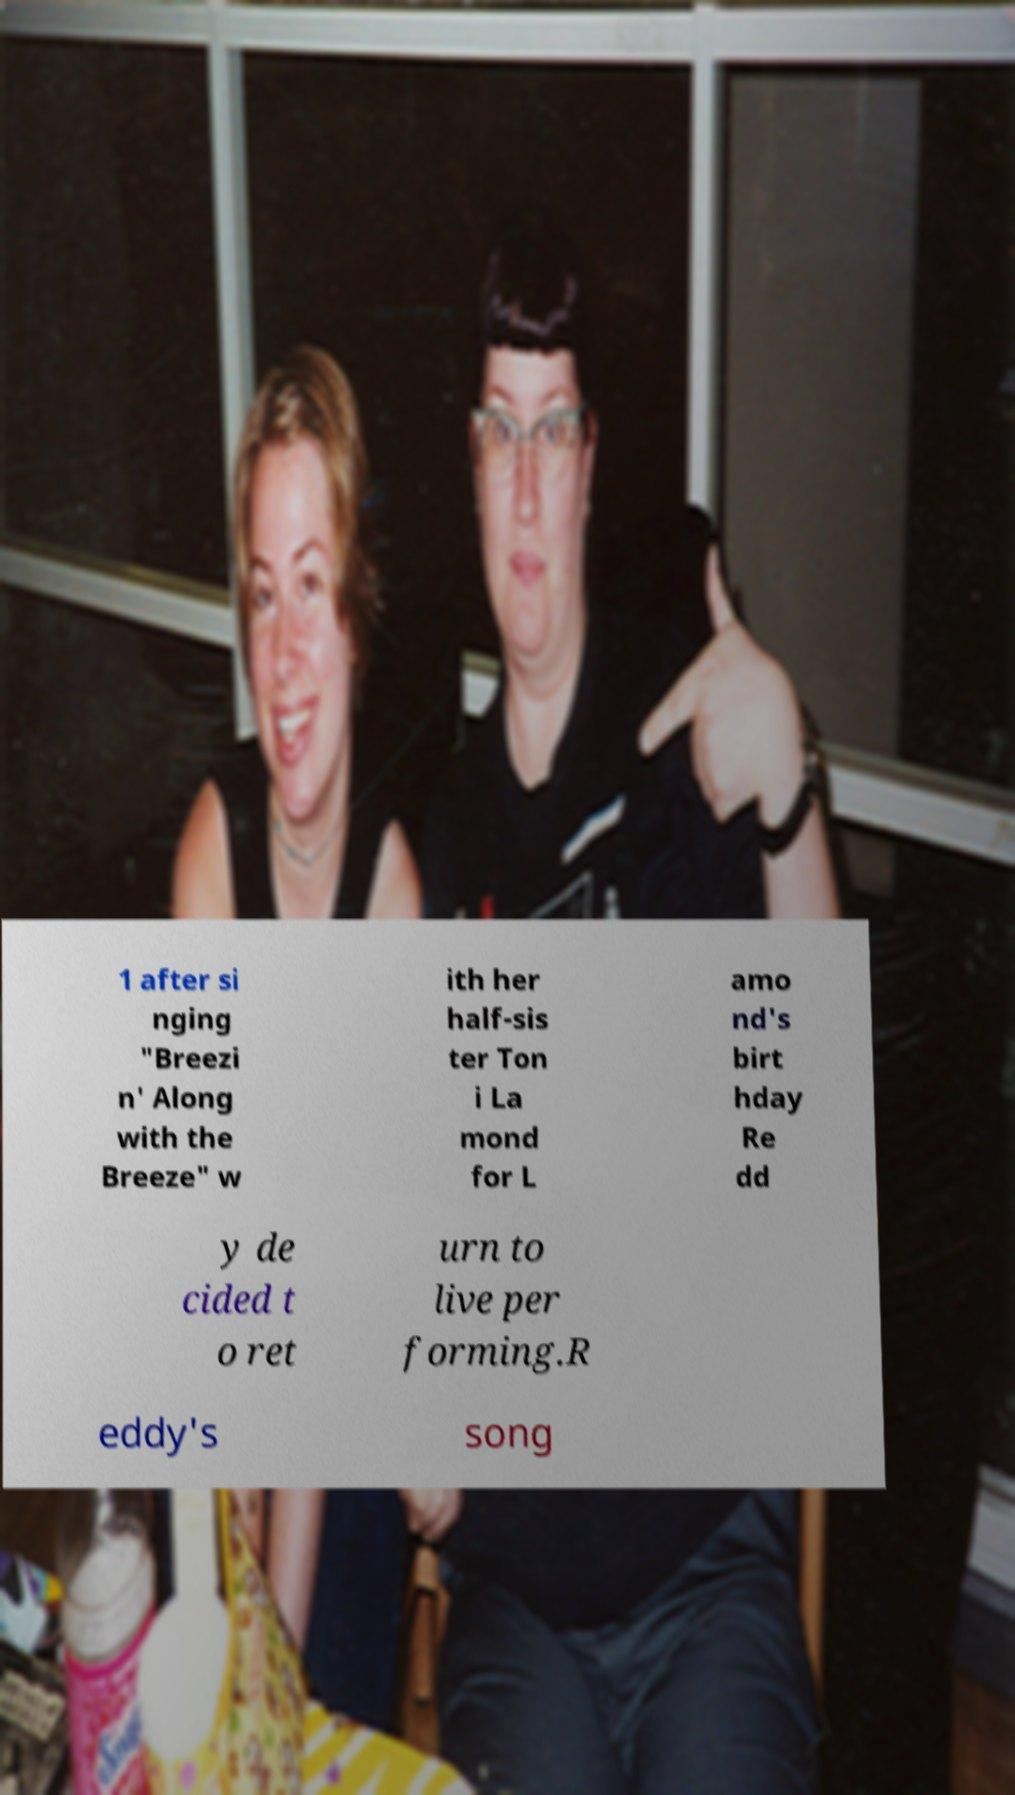Could you extract and type out the text from this image? 1 after si nging "Breezi n' Along with the Breeze" w ith her half-sis ter Ton i La mond for L amo nd's birt hday Re dd y de cided t o ret urn to live per forming.R eddy's song 